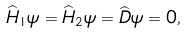Convert formula to latex. <formula><loc_0><loc_0><loc_500><loc_500>\widehat { H } _ { 1 } \psi = \widehat { H } _ { 2 } \psi = \widehat { D } \psi = 0 ,</formula> 